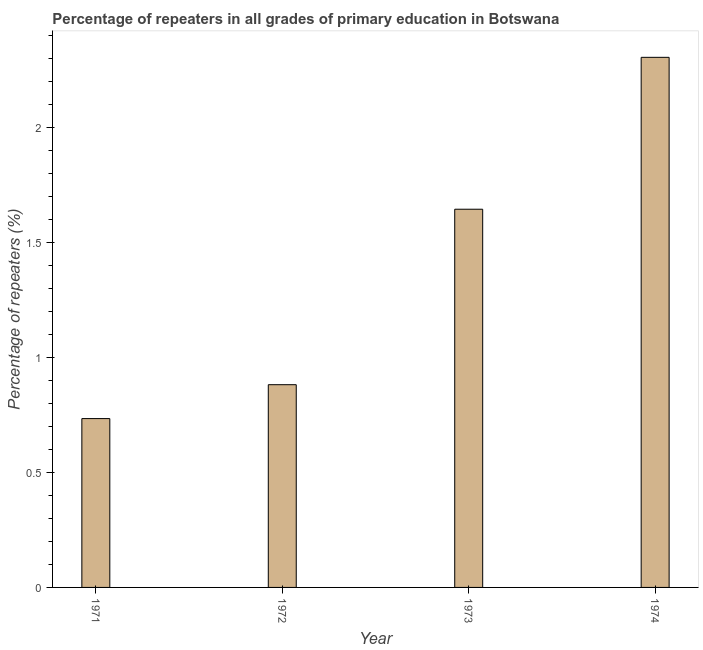What is the title of the graph?
Provide a short and direct response. Percentage of repeaters in all grades of primary education in Botswana. What is the label or title of the X-axis?
Provide a short and direct response. Year. What is the label or title of the Y-axis?
Keep it short and to the point. Percentage of repeaters (%). What is the percentage of repeaters in primary education in 1974?
Your answer should be very brief. 2.31. Across all years, what is the maximum percentage of repeaters in primary education?
Your response must be concise. 2.31. Across all years, what is the minimum percentage of repeaters in primary education?
Your answer should be compact. 0.73. In which year was the percentage of repeaters in primary education maximum?
Your response must be concise. 1974. What is the sum of the percentage of repeaters in primary education?
Offer a terse response. 5.57. What is the difference between the percentage of repeaters in primary education in 1971 and 1972?
Your answer should be compact. -0.15. What is the average percentage of repeaters in primary education per year?
Ensure brevity in your answer.  1.39. What is the median percentage of repeaters in primary education?
Your response must be concise. 1.26. In how many years, is the percentage of repeaters in primary education greater than 1.7 %?
Provide a short and direct response. 1. What is the ratio of the percentage of repeaters in primary education in 1971 to that in 1972?
Keep it short and to the point. 0.83. Is the difference between the percentage of repeaters in primary education in 1971 and 1974 greater than the difference between any two years?
Offer a terse response. Yes. What is the difference between the highest and the second highest percentage of repeaters in primary education?
Provide a short and direct response. 0.66. What is the difference between the highest and the lowest percentage of repeaters in primary education?
Provide a short and direct response. 1.57. How many bars are there?
Ensure brevity in your answer.  4. Are all the bars in the graph horizontal?
Give a very brief answer. No. How many years are there in the graph?
Give a very brief answer. 4. What is the Percentage of repeaters (%) of 1971?
Your response must be concise. 0.73. What is the Percentage of repeaters (%) in 1972?
Provide a succinct answer. 0.88. What is the Percentage of repeaters (%) in 1973?
Ensure brevity in your answer.  1.64. What is the Percentage of repeaters (%) in 1974?
Your answer should be compact. 2.31. What is the difference between the Percentage of repeaters (%) in 1971 and 1972?
Your answer should be compact. -0.15. What is the difference between the Percentage of repeaters (%) in 1971 and 1973?
Provide a short and direct response. -0.91. What is the difference between the Percentage of repeaters (%) in 1971 and 1974?
Give a very brief answer. -1.57. What is the difference between the Percentage of repeaters (%) in 1972 and 1973?
Your answer should be very brief. -0.76. What is the difference between the Percentage of repeaters (%) in 1972 and 1974?
Your answer should be compact. -1.42. What is the difference between the Percentage of repeaters (%) in 1973 and 1974?
Offer a very short reply. -0.66. What is the ratio of the Percentage of repeaters (%) in 1971 to that in 1972?
Your response must be concise. 0.83. What is the ratio of the Percentage of repeaters (%) in 1971 to that in 1973?
Your answer should be very brief. 0.45. What is the ratio of the Percentage of repeaters (%) in 1971 to that in 1974?
Provide a succinct answer. 0.32. What is the ratio of the Percentage of repeaters (%) in 1972 to that in 1973?
Keep it short and to the point. 0.54. What is the ratio of the Percentage of repeaters (%) in 1972 to that in 1974?
Your answer should be very brief. 0.38. What is the ratio of the Percentage of repeaters (%) in 1973 to that in 1974?
Your response must be concise. 0.71. 